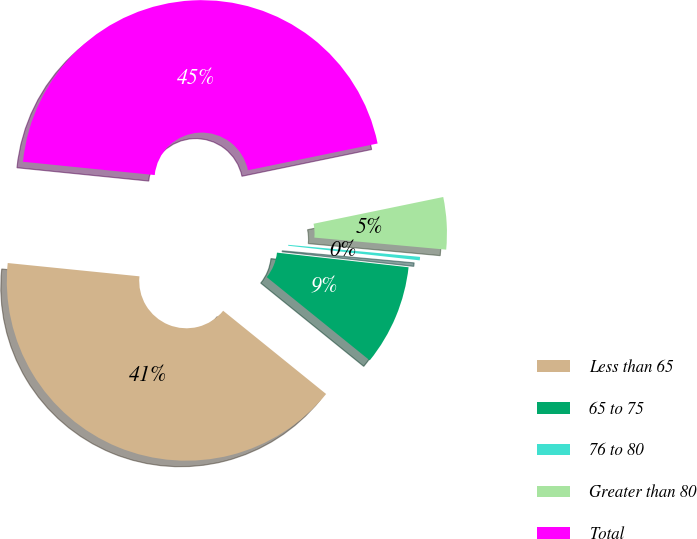Convert chart to OTSL. <chart><loc_0><loc_0><loc_500><loc_500><pie_chart><fcel>Less than 65<fcel>65 to 75<fcel>76 to 80<fcel>Greater than 80<fcel>Total<nl><fcel>40.78%<fcel>9.06%<fcel>0.31%<fcel>4.69%<fcel>45.16%<nl></chart> 